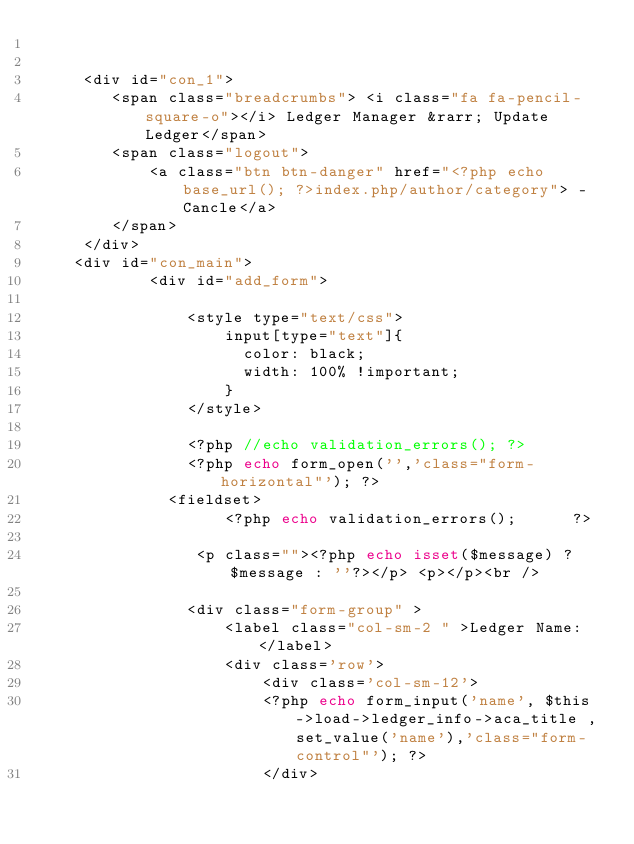Convert code to text. <code><loc_0><loc_0><loc_500><loc_500><_PHP_>
 
	 <div id="con_1">
		<span class="breadcrumbs"> <i class="fa fa-pencil-square-o"></i> Ledger Manager &rarr; Update Ledger</span>
	 	<span class="logout"> 
			<a class="btn btn-danger" href="<?php echo base_url(); ?>index.php/author/category"> -Cancle</a>
		</span>	
	 </div>
	<div id="con_main">
			<div id="add_form">

				<style type="text/css">
					input[type="text"]{
					  color: black;
					  width: 100% !important;
					}
				</style>

				<?php //echo validation_errors(); ?>
				<?php echo form_open('','class="form-horizontal"'); ?>	
              <fieldset>
                	<?php echo validation_errors(); 	 ?>	
                                    			
				 <p class=""><?php echo isset($message) ? $message : ''?></p> <p></p><br />
	
				<div class="form-group" >
					<label class="col-sm-2 " >Ledger Name: </label>
					<div class='row'>
			            <div class='col-sm-12'>
						<?php echo form_input('name', $this->load->ledger_info->aca_title ,set_value('name'),'class="form-control"'); ?>
			            </div></code> 